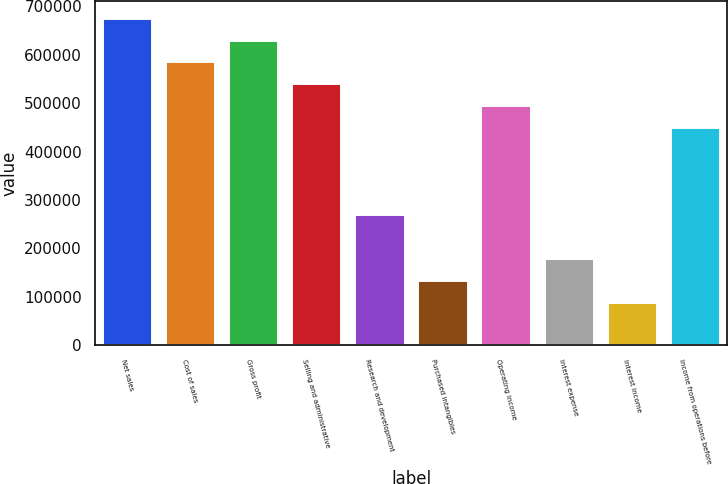Convert chart. <chart><loc_0><loc_0><loc_500><loc_500><bar_chart><fcel>Net sales<fcel>Cost of sales<fcel>Gross profit<fcel>Selling and administrative<fcel>Research and development<fcel>Purchased intangibles<fcel>Operating income<fcel>Interest expense<fcel>Interest income<fcel>Income from operations before<nl><fcel>676672<fcel>586449<fcel>631561<fcel>541338<fcel>270669<fcel>135335<fcel>496226<fcel>180447<fcel>90223.8<fcel>451115<nl></chart> 